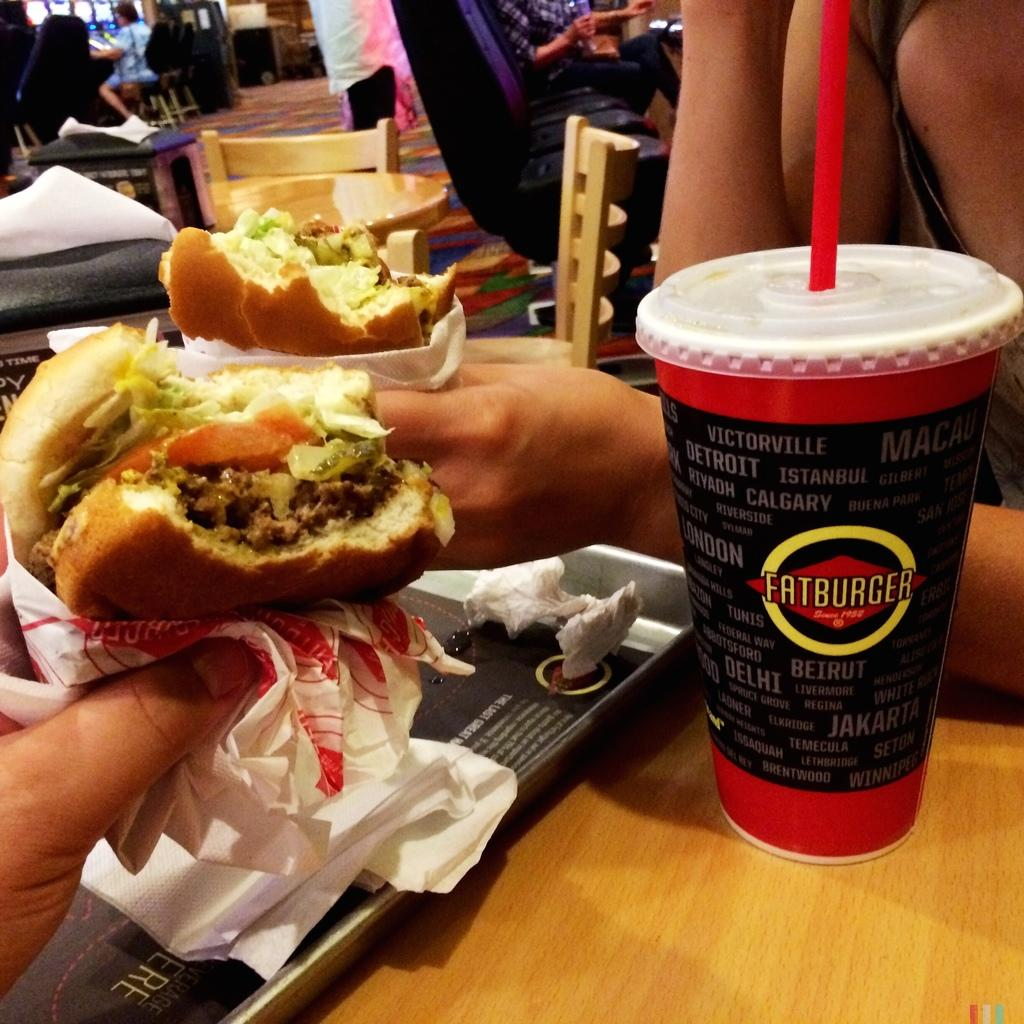What type of furniture is visible in the image? There are tables and chairs in the image. Where are the people located in the image? There are people at the top of the image and people holding burgers in the middle of the image. What is on the right side of the image? There is a glass on the right side of the image. Is there a stream of water flowing through the image? No, there is no stream of water present in the image. What type of question is being asked by the people in the image? There is no indication of a question being asked by the people in the image. 